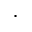<formula> <loc_0><loc_0><loc_500><loc_500>.</formula> 